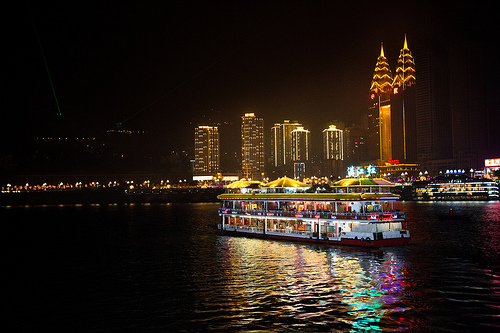Are there any rackets or umbrellas that are yellow? Yes, there are yellow umbrellas present in the image. 